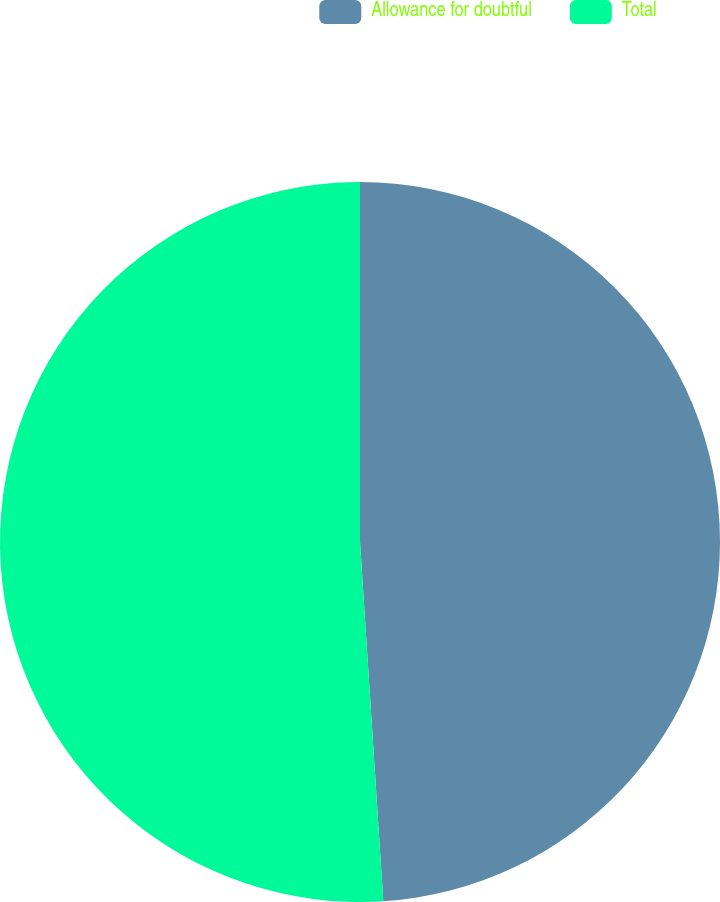Convert chart to OTSL. <chart><loc_0><loc_0><loc_500><loc_500><pie_chart><fcel>Allowance for doubtful<fcel>Total<nl><fcel>48.97%<fcel>51.03%<nl></chart> 